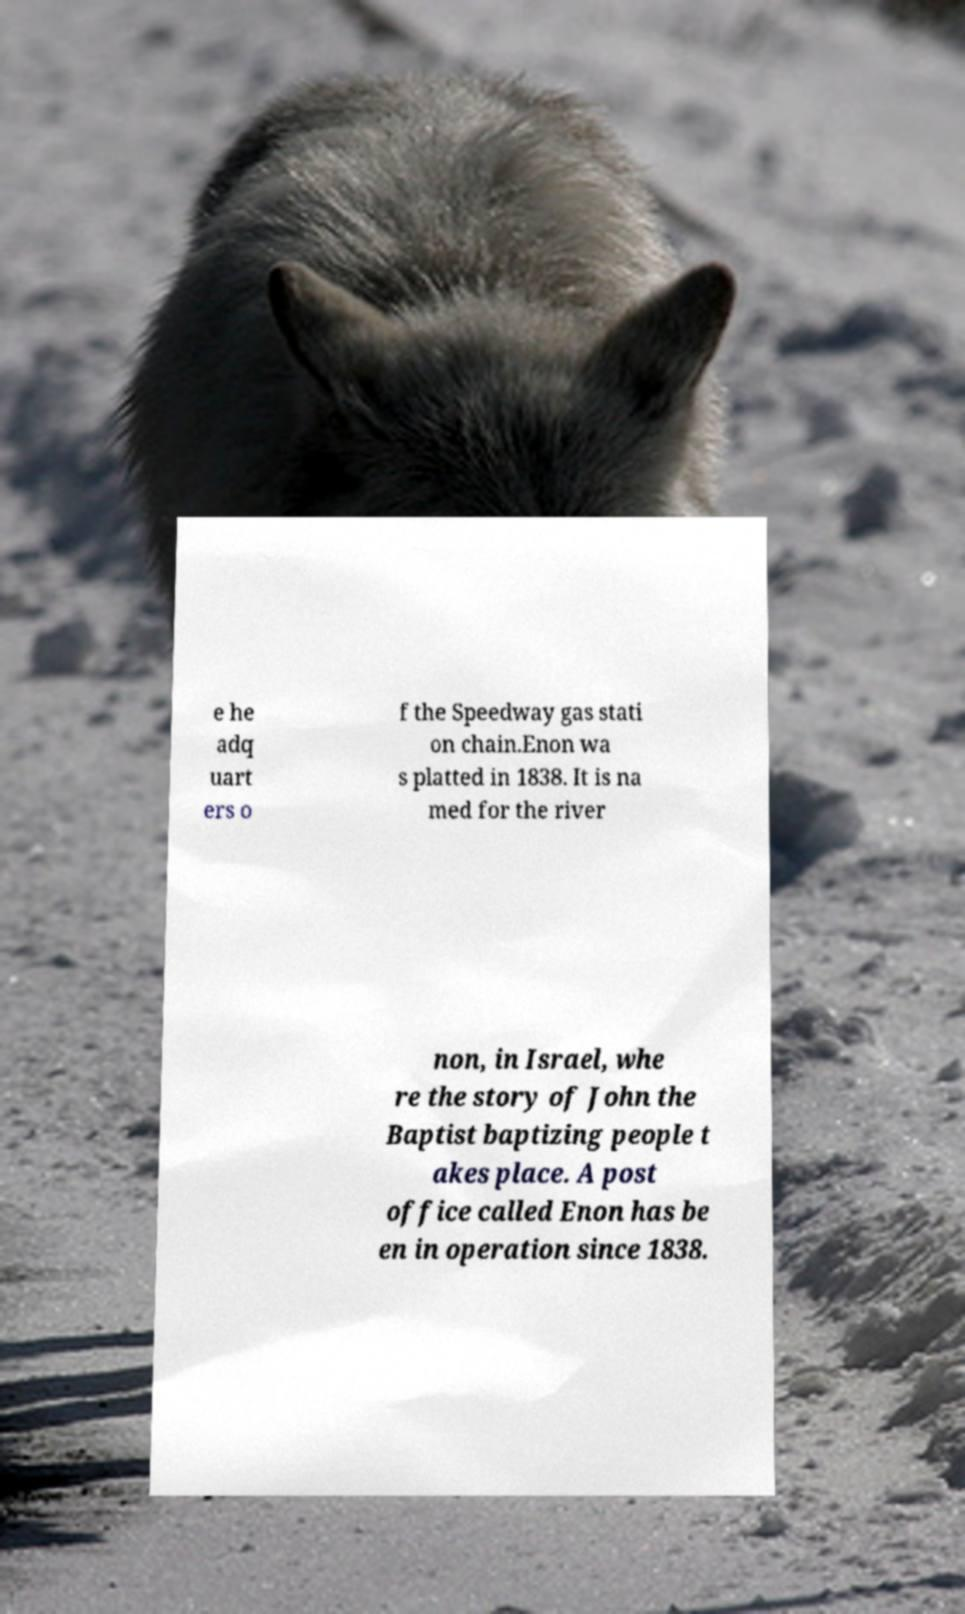I need the written content from this picture converted into text. Can you do that? e he adq uart ers o f the Speedway gas stati on chain.Enon wa s platted in 1838. It is na med for the river non, in Israel, whe re the story of John the Baptist baptizing people t akes place. A post office called Enon has be en in operation since 1838. 